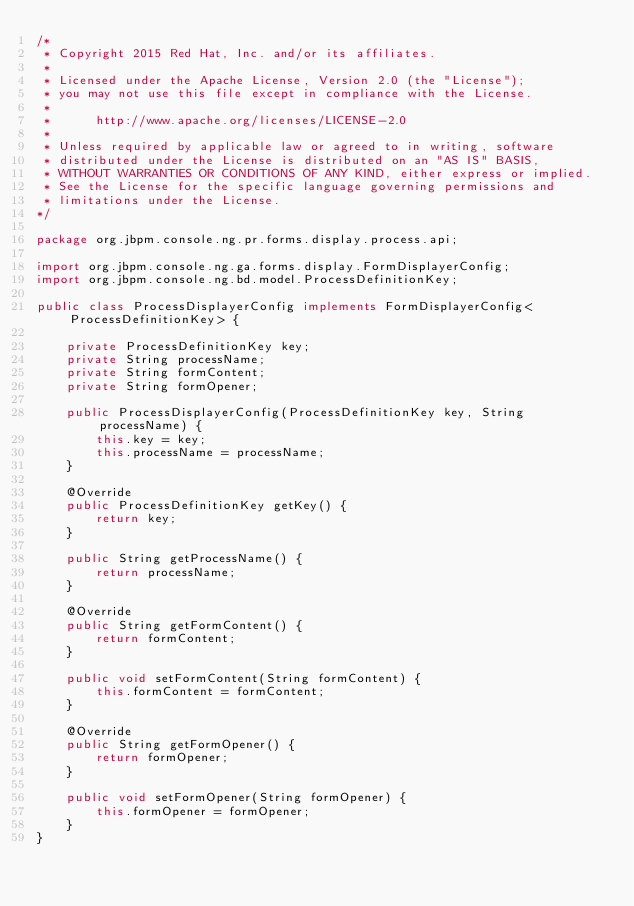Convert code to text. <code><loc_0><loc_0><loc_500><loc_500><_Java_>/*
 * Copyright 2015 Red Hat, Inc. and/or its affiliates.
 *
 * Licensed under the Apache License, Version 2.0 (the "License");
 * you may not use this file except in compliance with the License.
 * 
 *      http://www.apache.org/licenses/LICENSE-2.0
 *
 * Unless required by applicable law or agreed to in writing, software
 * distributed under the License is distributed on an "AS IS" BASIS,
 * WITHOUT WARRANTIES OR CONDITIONS OF ANY KIND, either express or implied.
 * See the License for the specific language governing permissions and
 * limitations under the License.
*/

package org.jbpm.console.ng.pr.forms.display.process.api;

import org.jbpm.console.ng.ga.forms.display.FormDisplayerConfig;
import org.jbpm.console.ng.bd.model.ProcessDefinitionKey;

public class ProcessDisplayerConfig implements FormDisplayerConfig<ProcessDefinitionKey> {

    private ProcessDefinitionKey key;
    private String processName;
    private String formContent;
    private String formOpener;

    public ProcessDisplayerConfig(ProcessDefinitionKey key, String processName) {
        this.key = key;
        this.processName = processName;
    }

    @Override
    public ProcessDefinitionKey getKey() {
        return key;
    }

    public String getProcessName() {
        return processName;
    }

    @Override
    public String getFormContent() {
        return formContent;
    }

    public void setFormContent(String formContent) {
        this.formContent = formContent;
    }

    @Override
    public String getFormOpener() {
        return formOpener;
    }

    public void setFormOpener(String formOpener) {
        this.formOpener = formOpener;
    }
}
</code> 